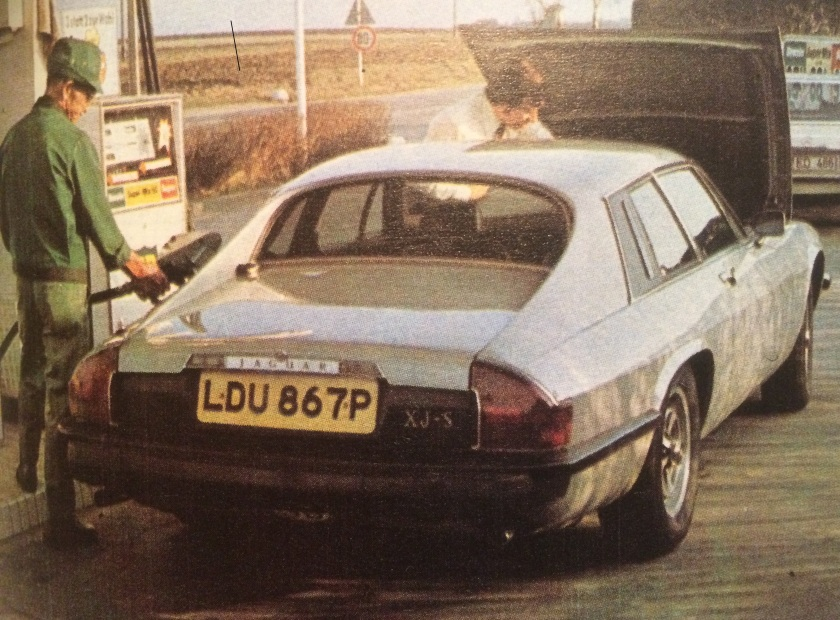Suppose this photograph is part of a vintage advertisement. What might be the advertisement's message or theme? As part of a vintage advertisement, the photograph could be promoting the reliability and elegance of the Jaguar XJ-S. The message could emphasize the car's suitability for long journeys, high performance, and style. The presence of the uniformed attendant at the gas station highlights the exceptional service and attention to detail associated with owning a luxury car like the Jaguar. The overall theme might be about the superior driving experience and prestige that comes with owning such an iconic vehicle. How might the advertisement appeal to potential buyers of that time? In the late 1970s, potential buyers would be drawn to various aspects promoted in this advertisement. The Jaguar XJ-S would appeal to those looking for a blend of performance, luxury, and status. Emphasizing the car’s robust engineering, elegant design, and the personalized service one might expect at gas stations would cater to a clientele that values both function and form. Additionally, highlighting the car’s feature set, such as advanced technology (for the time), interior comfort, and the prestige of owning a Jaguar, would resonate well with discerning buyers seeking a premium driving experience. Imagine if this photograph was part of a mystery novel. What role might it play in the story? In a mystery novel, this photograph could serve as a critical clue. Perhaps the car, identified as a Jaguar XJ-S, belongs to a key suspect or a mysterious figure central to the plot. The open boot might suggest hidden items or evidence that need to be discovered. The fuel station attendant could be an unknowing witness or an accomplice, offering testimony or clues about the suspect’s movements. The vintage setting adds to the novel's atmosphere, drawing readers into a bygone era where the tools of investigation were less advanced, adding intrigue and challenge to the protagonist’s quest to solve the mystery. 